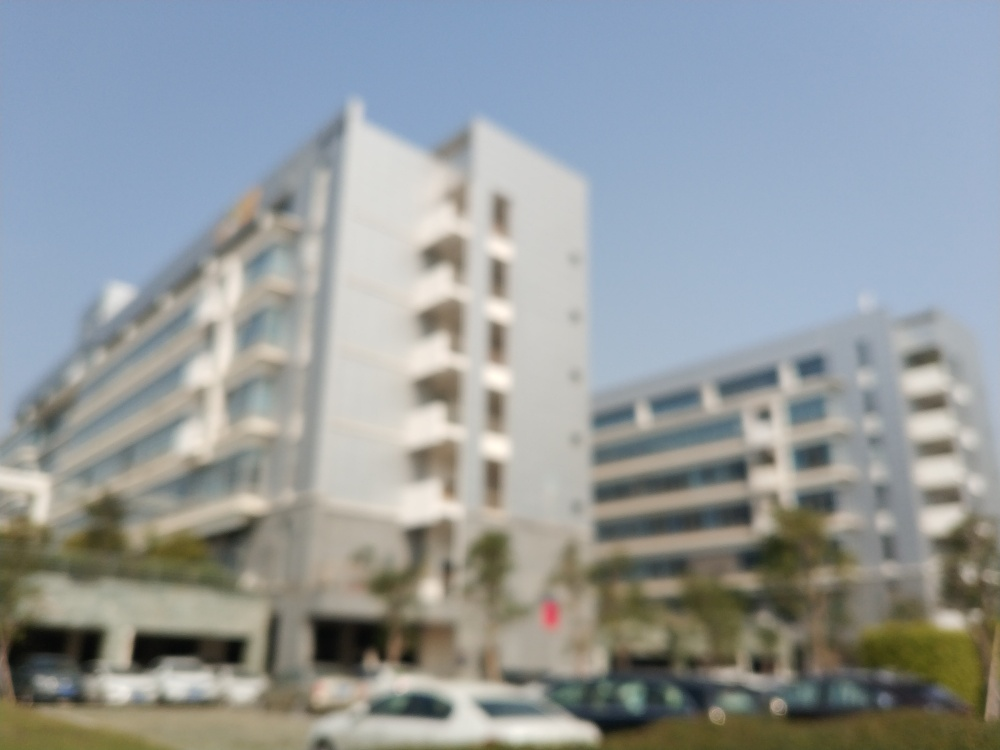What time of day do you think it is based on the lighting in the photo? Given the bright and diffuse quality of the light, it suggests the photo might have been taken during the day, possibly midday when the sun is high and light is plentiful, even though specific details are not discernible. 